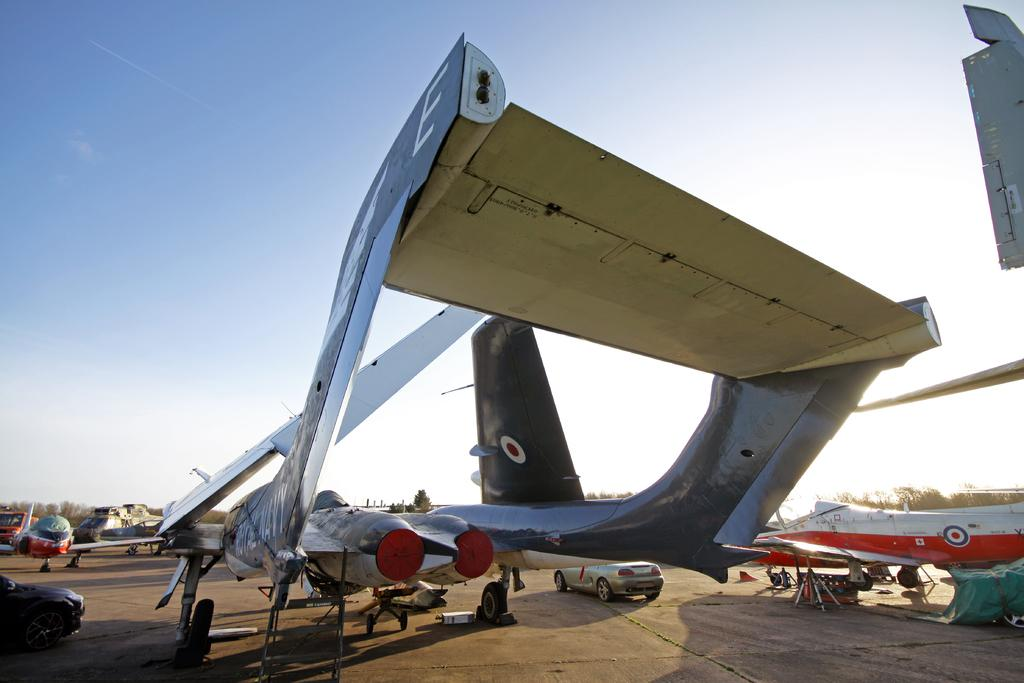What can be seen on the runway in the image? There are aircraft and vehicles on the runway in the image. What is visible in the background of the image? There are trees in the background of the image. What can be seen in the sky in the image? There are clouds in the sky, and the sky is blue. What type of vegetable is being used as a hat by one of the aircraft in the image? There is no vegetable or hat present on any of the aircraft in the image. 